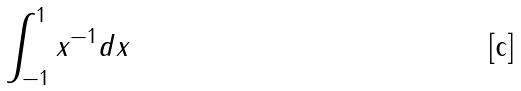Convert formula to latex. <formula><loc_0><loc_0><loc_500><loc_500>\int _ { - 1 } ^ { 1 } x ^ { - 1 } d x</formula> 